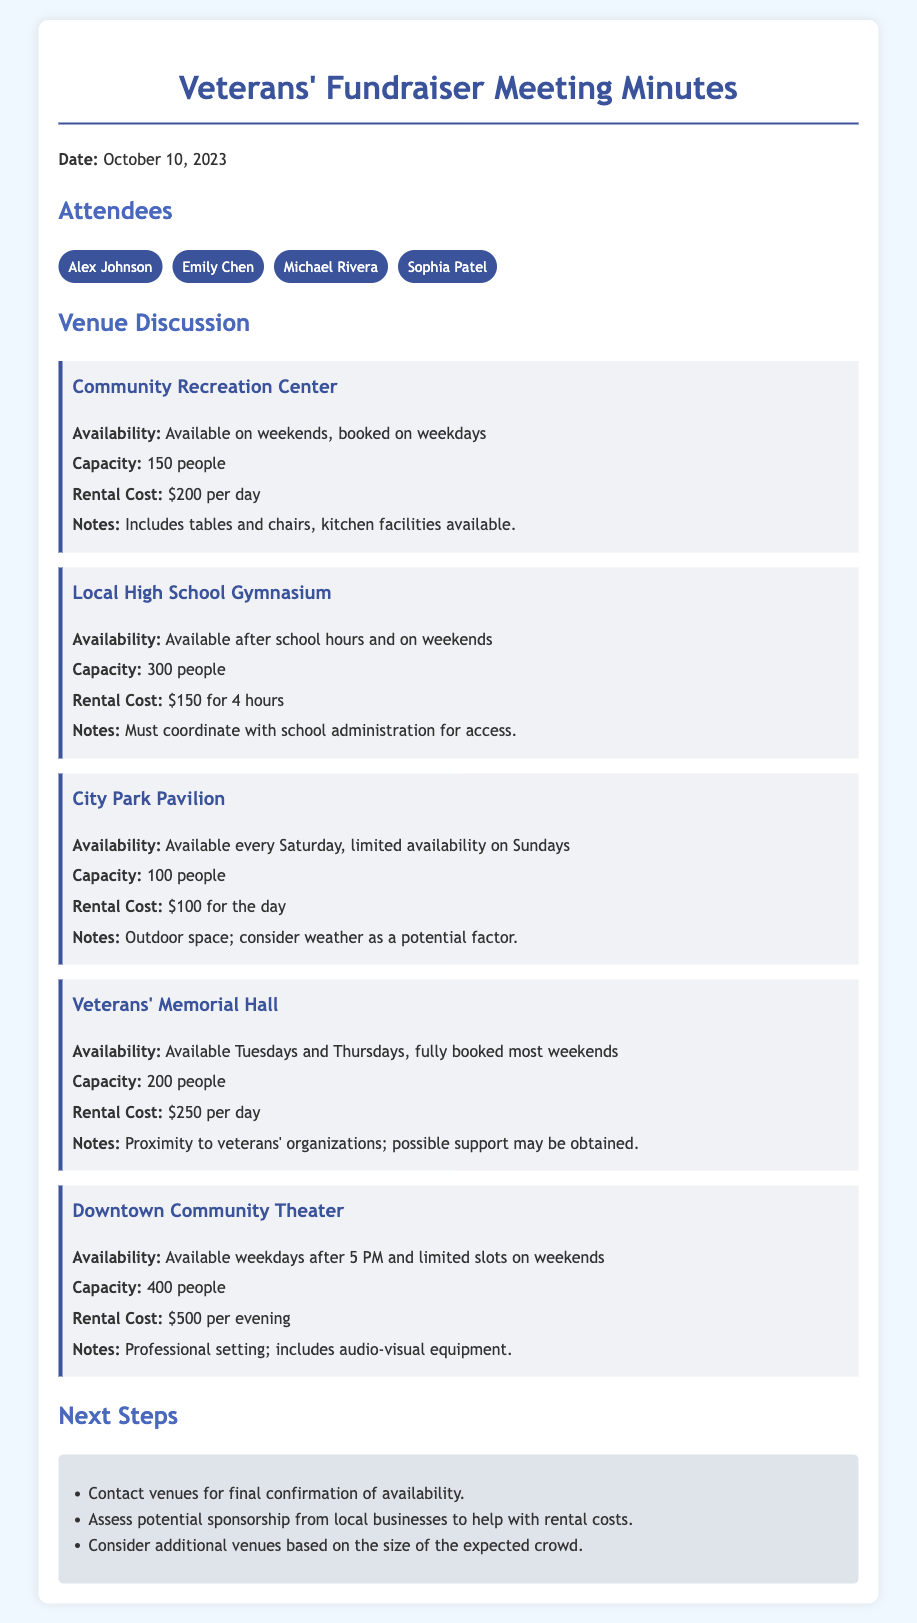What is the capacity of the Local High School Gymnasium? The capacity is stated in the document for the Local High School Gymnasium, which is 300 people.
Answer: 300 people What is the rental cost of the Community Recreation Center? The document specifies the rental cost for the Community Recreation Center as $200 per day.
Answer: $200 per day On which days is the Veterans' Memorial Hall available? The availability days for the Veterans' Memorial Hall are mentioned in the document as Tuesdays and Thursdays.
Answer: Tuesdays and Thursdays What is the maximum capacity of the Downtown Community Theater? The document lists the capacity of the Downtown Community Theater as 400 people, which is the maximum they can accommodate.
Answer: 400 people How much does it cost to rent the City Park Pavilion? The rental cost for the City Park Pavilion is clearly stated in the document as $100 for the day.
Answer: $100 for the day Which venue has kitchen facilities available? The document notes that the Community Recreation Center includes kitchen facilities.
Answer: Community Recreation Center What are the next steps mentioned in the meeting minutes? The meeting concludes with a list of next steps, among which is contacting venues for final confirmation.
Answer: Contact venues for final confirmation of availability What is the weather consideration mentioned for the City Park Pavilion? The document highlights that weather should be considered as a potential factor for the outdoor space of the City Park Pavilion.
Answer: Weather as a potential factor What is the availability schedule for the Downtown Community Theater? The document provides the availability for the Downtown Community Theater as weekdays after 5 PM and limited slots on weekends.
Answer: Weekdays after 5 PM and limited slots on weekends 